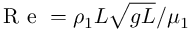Convert formula to latex. <formula><loc_0><loc_0><loc_500><loc_500>R e = \rho _ { 1 } L \sqrt { g L } / \mu _ { 1 }</formula> 